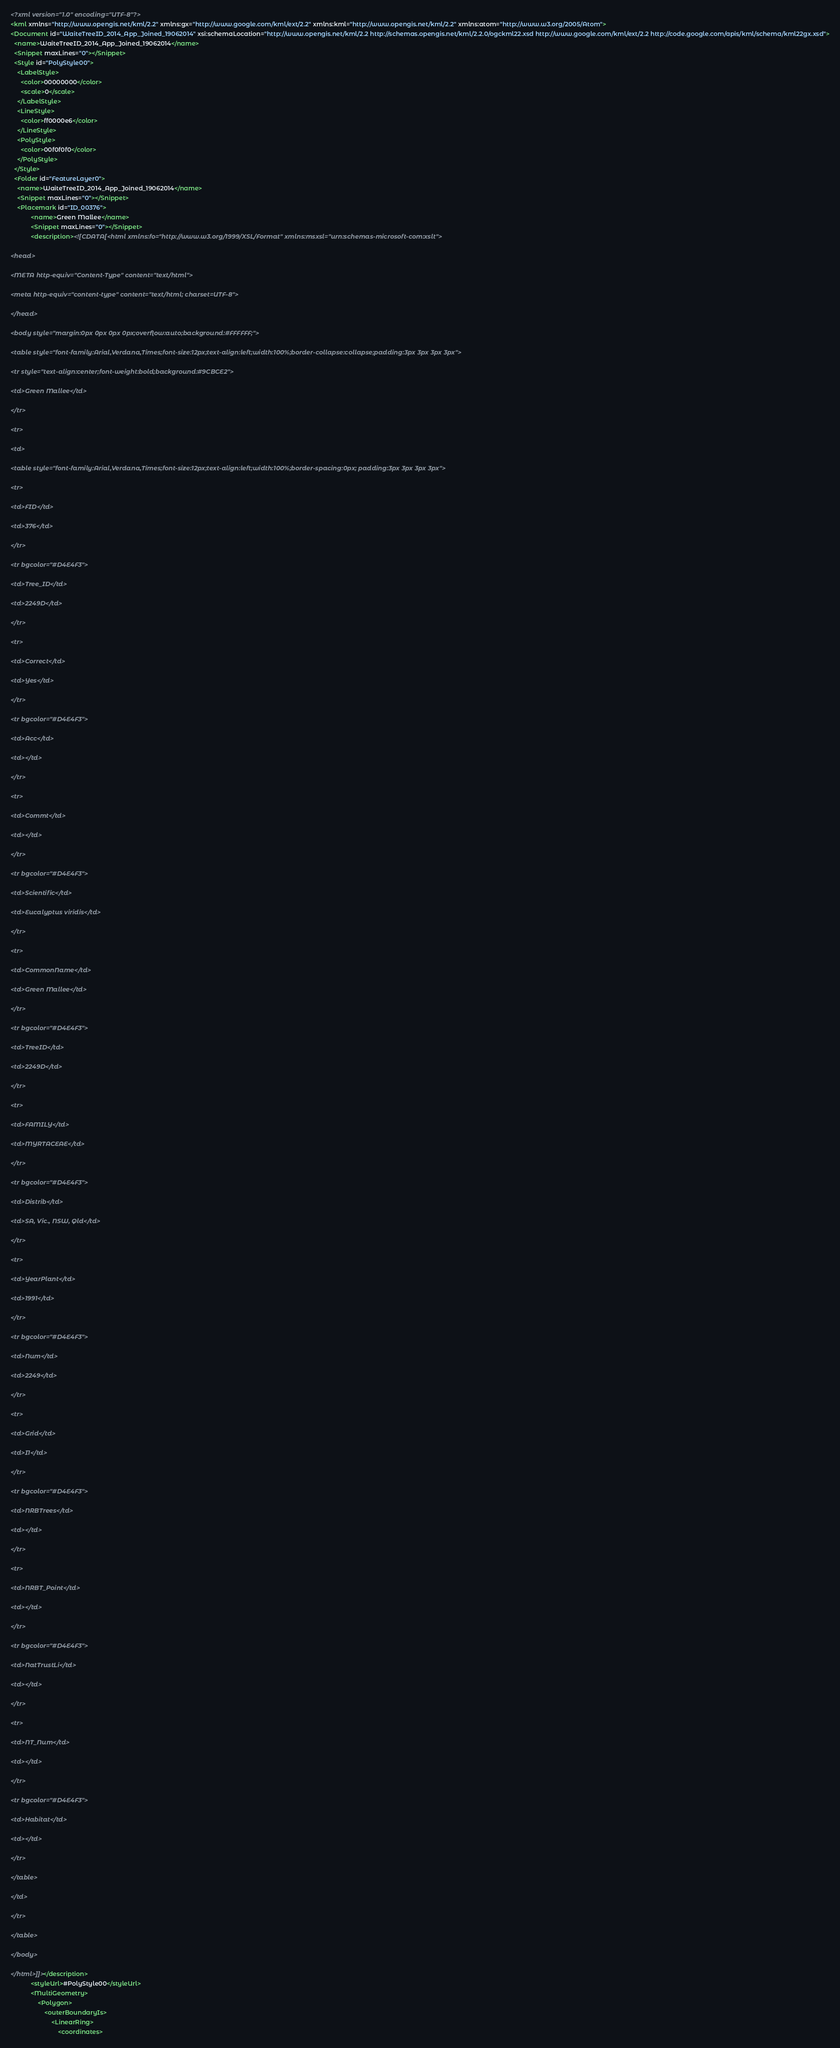Convert code to text. <code><loc_0><loc_0><loc_500><loc_500><_XML_><?xml version="1.0" encoding="UTF-8"?>
<kml xmlns="http://www.opengis.net/kml/2.2" xmlns:gx="http://www.google.com/kml/ext/2.2" xmlns:kml="http://www.opengis.net/kml/2.2" xmlns:atom="http://www.w3.org/2005/Atom">
<Document id="WaiteTreeID_2014_App_Joined_19062014" xsi:schemaLocation="http://www.opengis.net/kml/2.2 http://schemas.opengis.net/kml/2.2.0/ogckml22.xsd http://www.google.com/kml/ext/2.2 http://code.google.com/apis/kml/schema/kml22gx.xsd">
  <name>WaiteTreeID_2014_App_Joined_19062014</name>
  <Snippet maxLines="0"></Snippet>
  <Style id="PolyStyle00">
    <LabelStyle>
      <color>00000000</color>
      <scale>0</scale>
    </LabelStyle>
    <LineStyle>
      <color>ff0000e6</color>
    </LineStyle>
    <PolyStyle>
      <color>00f0f0f0</color>
    </PolyStyle>
  </Style>
  <Folder id="FeatureLayer0">
    <name>WaiteTreeID_2014_App_Joined_19062014</name>
    <Snippet maxLines="0"></Snippet>
	<Placemark id="ID_00376">
			<name>Green Mallee</name>
			<Snippet maxLines="0"></Snippet>
			<description><![CDATA[<html xmlns:fo="http://www.w3.org/1999/XSL/Format" xmlns:msxsl="urn:schemas-microsoft-com:xslt">

<head>

<META http-equiv="Content-Type" content="text/html">

<meta http-equiv="content-type" content="text/html; charset=UTF-8">

</head>

<body style="margin:0px 0px 0px 0px;overflow:auto;background:#FFFFFF;">

<table style="font-family:Arial,Verdana,Times;font-size:12px;text-align:left;width:100%;border-collapse:collapse;padding:3px 3px 3px 3px">

<tr style="text-align:center;font-weight:bold;background:#9CBCE2">

<td>Green Mallee</td>

</tr>

<tr>

<td>

<table style="font-family:Arial,Verdana,Times;font-size:12px;text-align:left;width:100%;border-spacing:0px; padding:3px 3px 3px 3px">

<tr>

<td>FID</td>

<td>376</td>

</tr>

<tr bgcolor="#D4E4F3">

<td>Tree_ID</td>

<td>2249D</td>

</tr>

<tr>

<td>Correct</td>

<td>Yes</td>

</tr>

<tr bgcolor="#D4E4F3">

<td>Acc</td>

<td></td>

</tr>

<tr>

<td>Commt</td>

<td></td>

</tr>

<tr bgcolor="#D4E4F3">

<td>Scientific</td>

<td>Eucalyptus viridis</td>

</tr>

<tr>

<td>CommonName</td>

<td>Green Mallee</td>

</tr>

<tr bgcolor="#D4E4F3">

<td>TreeID</td>

<td>2249D</td>

</tr>

<tr>

<td>FAMILY</td>

<td>MYRTACEAE</td>

</tr>

<tr bgcolor="#D4E4F3">

<td>Distrib</td>

<td>SA, Vic., NSW, Qld</td>

</tr>

<tr>

<td>YearPlant</td>

<td>1991</td>

</tr>

<tr bgcolor="#D4E4F3">

<td>Num</td>

<td>2249</td>

</tr>

<tr>

<td>Grid</td>

<td>I1</td>

</tr>

<tr bgcolor="#D4E4F3">

<td>NRBTrees</td>

<td></td>

</tr>

<tr>

<td>NRBT_Point</td>

<td></td>

</tr>

<tr bgcolor="#D4E4F3">

<td>NatTrustLi</td>

<td></td>

</tr>

<tr>

<td>NT_Num</td>

<td></td>

</tr>

<tr bgcolor="#D4E4F3">

<td>Habitat</td>

<td></td>

</tr>

</table>

</td>

</tr>

</table>

</body>

</html>]]></description>
			<styleUrl>#PolyStyle00</styleUrl>
			<MultiGeometry>
				<Polygon>
					<outerBoundaryIs>
						<LinearRing>
							<coordinates></code> 